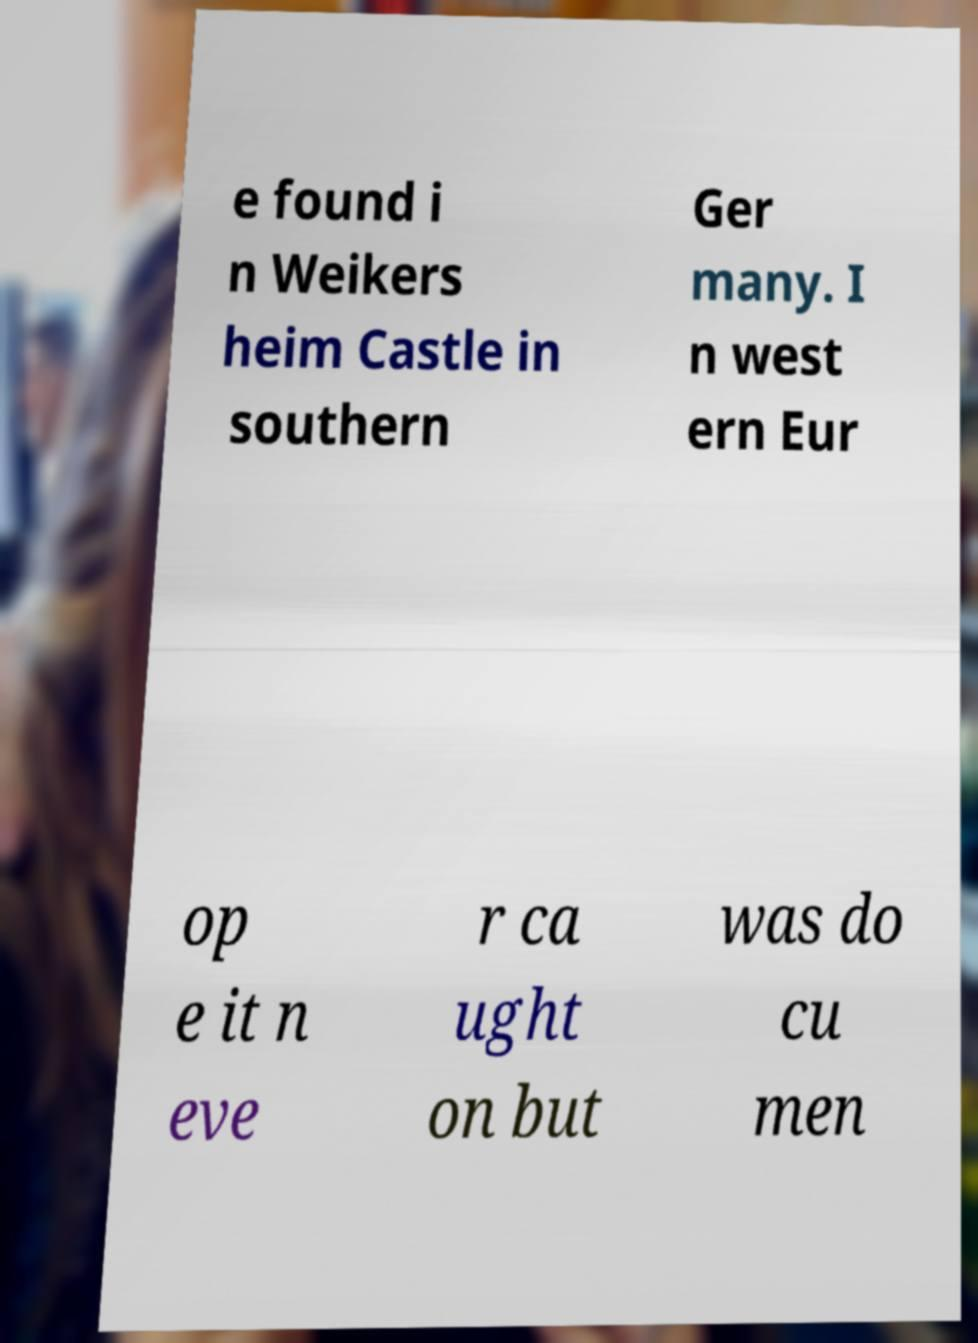Please read and relay the text visible in this image. What does it say? e found i n Weikers heim Castle in southern Ger many. I n west ern Eur op e it n eve r ca ught on but was do cu men 